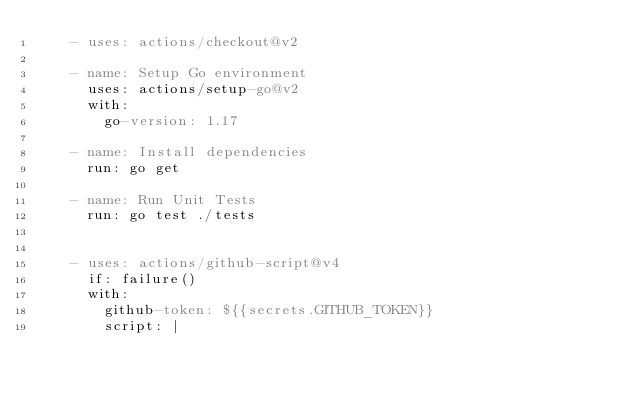<code> <loc_0><loc_0><loc_500><loc_500><_YAML_>    - uses: actions/checkout@v2

    - name: Setup Go environment
      uses: actions/setup-go@v2
      with:
        go-version: 1.17

    - name: Install dependencies
      run: go get

    - name: Run Unit Tests
      run: go test ./tests


    - uses: actions/github-script@v4
      if: failure()
      with:
        github-token: ${{secrets.GITHUB_TOKEN}}
        script: |</code> 